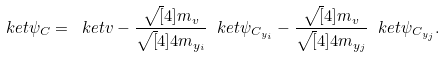<formula> <loc_0><loc_0><loc_500><loc_500>\ k e t { \psi _ { C } } = \ k e t { v } - \frac { \sqrt { [ } 4 ] { m _ { v } } } { \sqrt { [ } 4 ] { 4 m _ { y _ { i } } } } \ k e t { \psi _ { C _ { y _ { i } } } } - \frac { \sqrt { [ } 4 ] { m _ { v } } } { \sqrt { [ } 4 ] { 4 m _ { y _ { j } } } } \ k e t { \psi _ { C _ { y _ { j } } } } .</formula> 